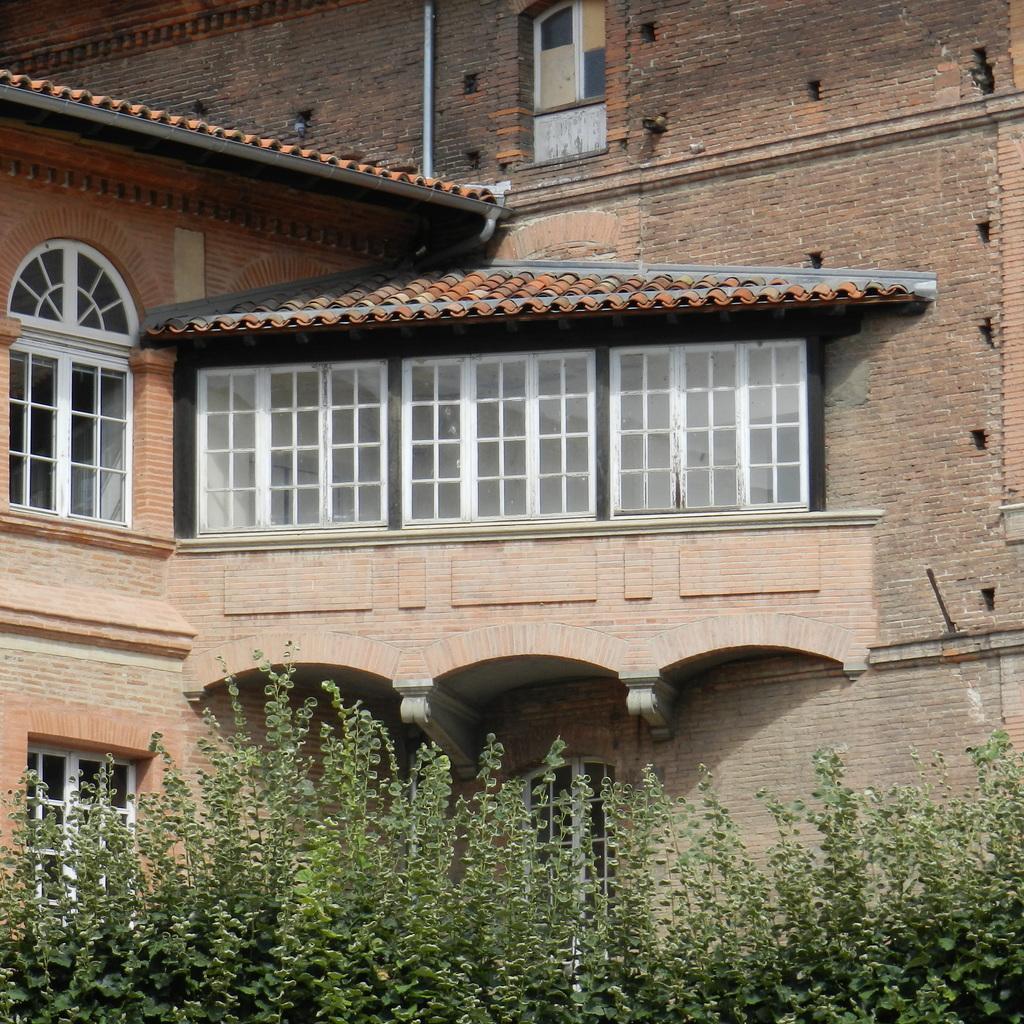Could you give a brief overview of what you see in this image? In this picture I can see a building and plants. I can also see windows and a white color pipe attached to the wall. 